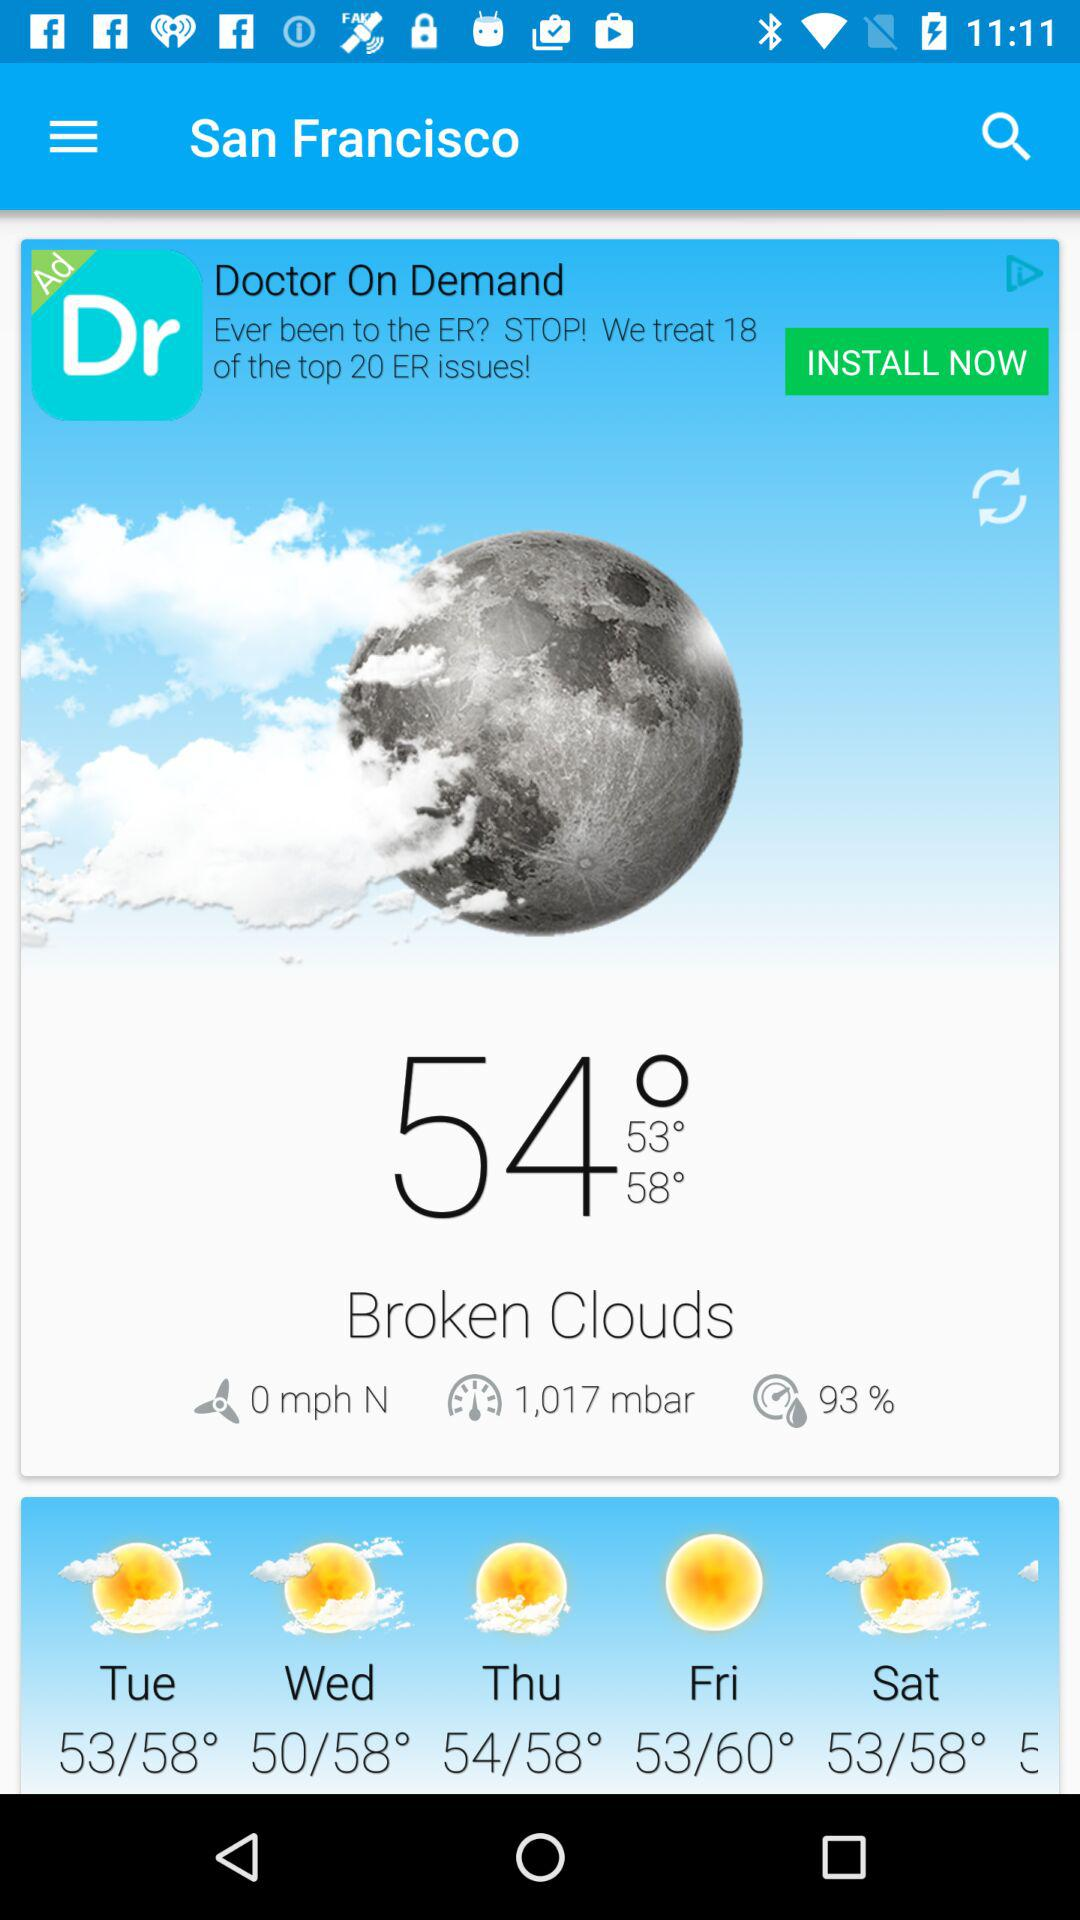How many days of the week are there in the forecast?
Answer the question using a single word or phrase. 5 